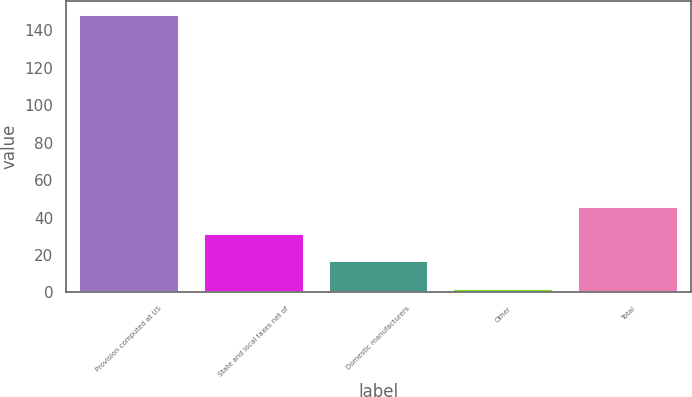<chart> <loc_0><loc_0><loc_500><loc_500><bar_chart><fcel>Provision computed at US<fcel>State and local taxes net of<fcel>Domestic manufacturers<fcel>Other<fcel>Total<nl><fcel>148.3<fcel>31.18<fcel>16.54<fcel>1.9<fcel>45.82<nl></chart> 